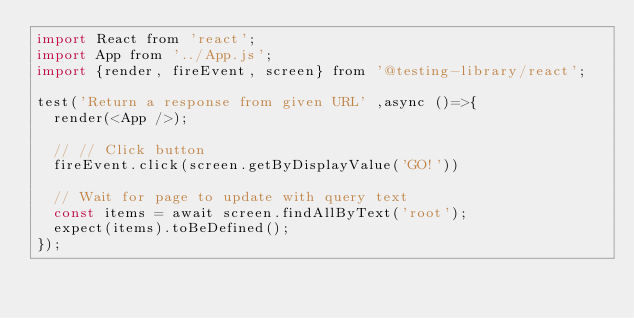<code> <loc_0><loc_0><loc_500><loc_500><_JavaScript_>import React from 'react';
import App from '../App.js';
import {render, fireEvent, screen} from '@testing-library/react';

test('Return a response from given URL' ,async ()=>{
  render(<App />);

  // // Click button
  fireEvent.click(screen.getByDisplayValue('GO!'))

  // Wait for page to update with query text
  const items = await screen.findAllByText('root');
  expect(items).toBeDefined();
});
</code> 